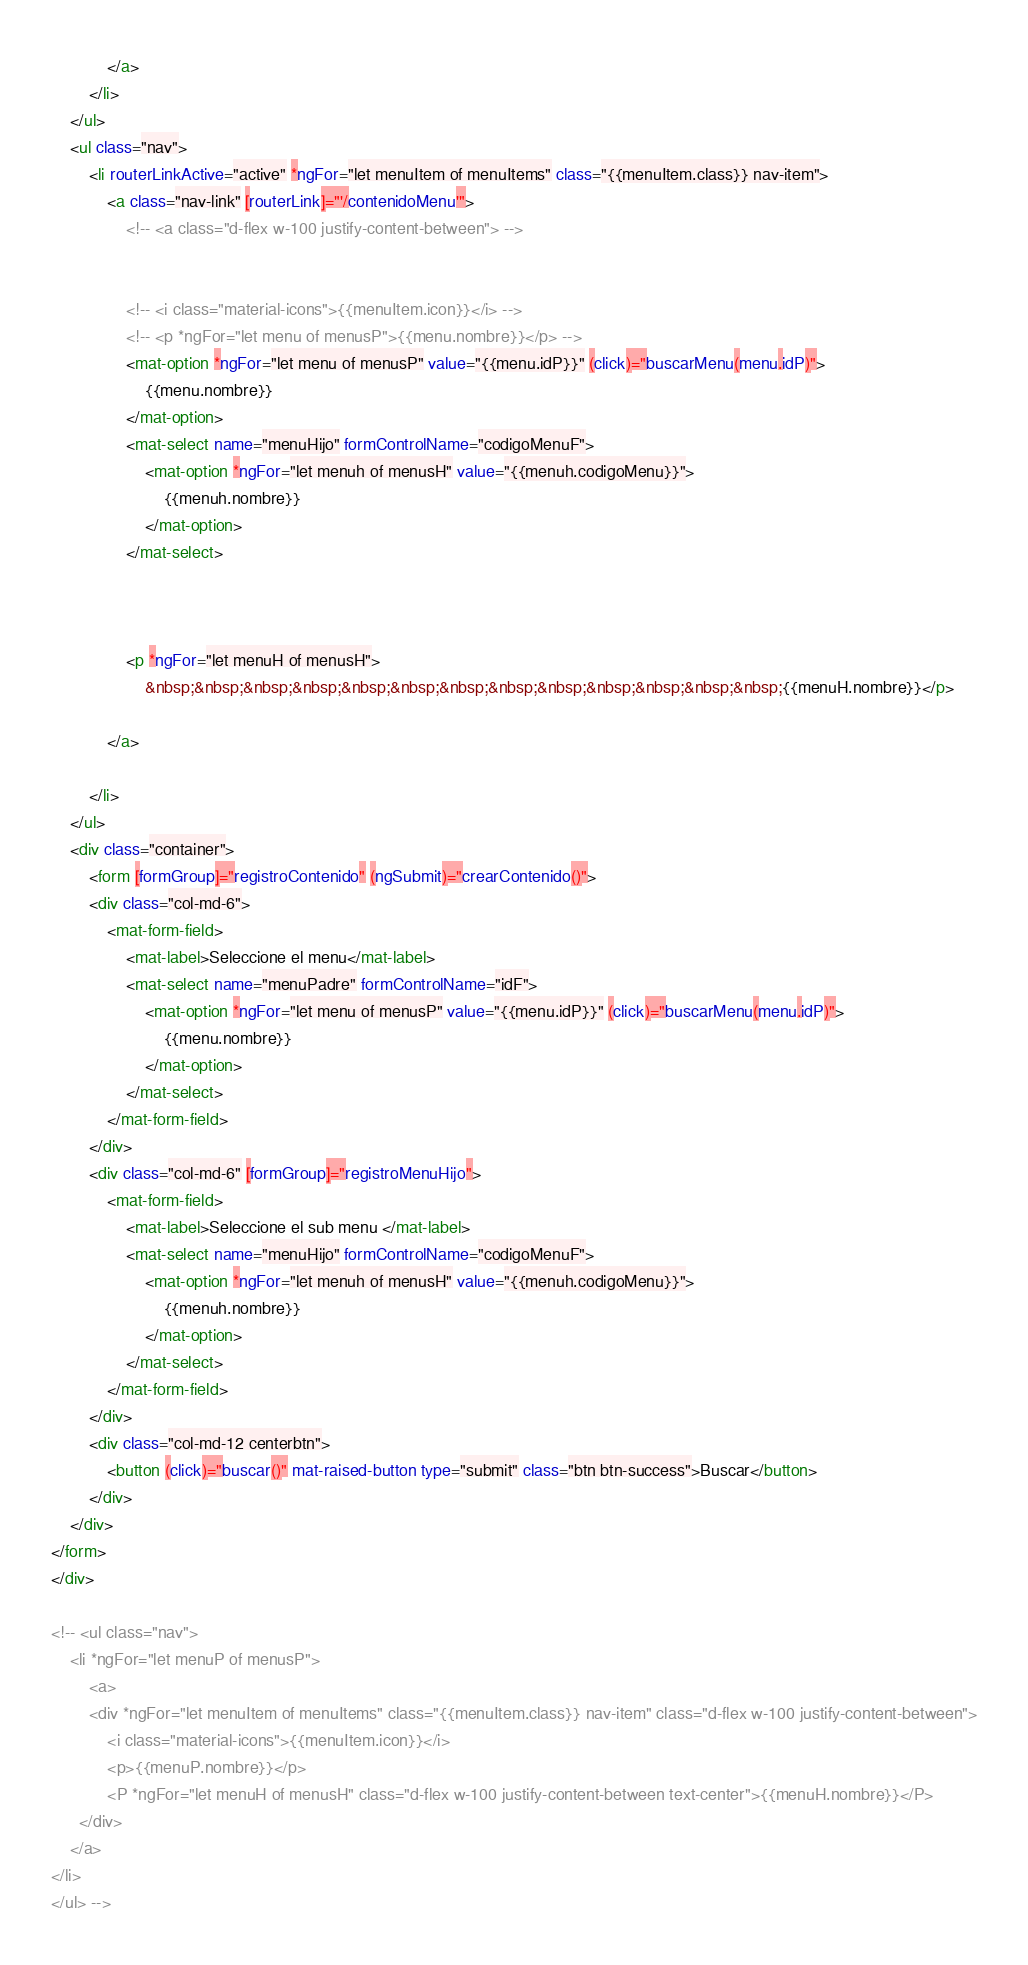<code> <loc_0><loc_0><loc_500><loc_500><_HTML_>            </a>
        </li>
    </ul>
    <ul class="nav">
        <li routerLinkActive="active" *ngFor="let menuItem of menuItems" class="{{menuItem.class}} nav-item">
            <a class="nav-link" [routerLink]="'/contenidoMenu'">
                <!-- <a class="d-flex w-100 justify-content-between"> -->


                <!-- <i class="material-icons">{{menuItem.icon}}</i> -->
                <!-- <p *ngFor="let menu of menusP">{{menu.nombre}}</p> -->
                <mat-option *ngFor="let menu of menusP" value="{{menu.idP}}" (click)="buscarMenu(menu.idP)">
                    {{menu.nombre}}
                </mat-option>
                <mat-select name="menuHijo" formControlName="codigoMenuF">
                    <mat-option *ngFor="let menuh of menusH" value="{{menuh.codigoMenu}}">
                        {{menuh.nombre}}
                    </mat-option>
                </mat-select>



                <p *ngFor="let menuH of menusH">
                    &nbsp;&nbsp;&nbsp;&nbsp;&nbsp;&nbsp;&nbsp;&nbsp;&nbsp;&nbsp;&nbsp;&nbsp;&nbsp;{{menuH.nombre}}</p>

            </a>

        </li>
    </ul>
    <div class="container">
        <form [formGroup]="registroContenido" (ngSubmit)="crearContenido()">
        <div class="col-md-6">
            <mat-form-field>
                <mat-label>Seleccione el menu</mat-label>
                <mat-select name="menuPadre" formControlName="idF">
                    <mat-option *ngFor="let menu of menusP" value="{{menu.idP}}" (click)="buscarMenu(menu.idP)">
                        {{menu.nombre}}
                    </mat-option>
                </mat-select>
            </mat-form-field>
        </div>
        <div class="col-md-6" [formGroup]="registroMenuHijo">
            <mat-form-field>
                <mat-label>Seleccione el sub menu </mat-label>
                <mat-select name="menuHijo" formControlName="codigoMenuF">
                    <mat-option *ngFor="let menuh of menusH" value="{{menuh.codigoMenu}}">
                        {{menuh.nombre}}
                    </mat-option>
                </mat-select>
            </mat-form-field>
        </div>
        <div class="col-md-12 centerbtn">
            <button (click)="buscar()" mat-raised-button type="submit" class="btn btn-success">Buscar</button>
        </div>
    </div>
</form>
</div>

<!-- <ul class="nav">
    <li *ngFor="let menuP of menusP">
        <a>
        <div *ngFor="let menuItem of menuItems" class="{{menuItem.class}} nav-item" class="d-flex w-100 justify-content-between">
            <i class="material-icons">{{menuItem.icon}}</i>
            <p>{{menuP.nombre}}</p>
            <P *ngFor="let menuH of menusH" class="d-flex w-100 justify-content-between text-center">{{menuH.nombre}}</P>
      </div>
    </a>
</li>
</ul> --></code> 